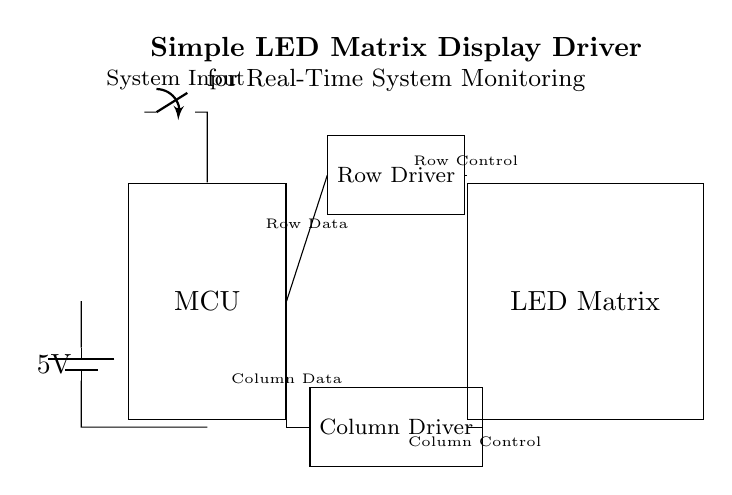what is the main component in this circuit diagram? The main component in this circuit is the Microcontroller (MCU), which controls the operation of the entire LED matrix display driver.
Answer: Microcontroller what type of display is being driven in this circuit? The display type in this circuit diagram is an LED Matrix, as indicated in the labeled component.
Answer: LED Matrix how many driver components are present in the circuit? There are two driver components present: a Row Driver and a Column Driver, each labeled in the diagram.
Answer: Two what is the supply voltage shown in this circuit? The supply voltage is indicated as 5 volts from the battery connected to the circuit.
Answer: 5 volts what is the purpose of the Row Control connection? The Row Control connection regulates the power and data to the rows of the LED matrix, allowing for selective activation of each row during operation.
Answer: Regulates row activation which component provides the input signal to the Microcontroller? The input signal to the Microcontroller comes from the System Input switch, which is connected directly to the MCU input.
Answer: System Input switch how are the Row Data and Column Data connected to the drivers? Row Data is connected directly from the Microcontroller to the Row Driver, while Column Data is routed from the MCU using a branching connection to the Column Driver.
Answer: Directly connected 